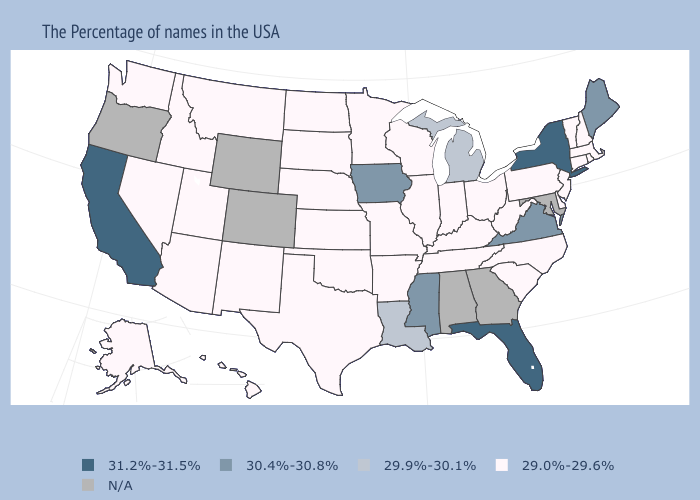Name the states that have a value in the range 29.0%-29.6%?
Give a very brief answer. Massachusetts, Rhode Island, New Hampshire, Vermont, Connecticut, New Jersey, Delaware, Pennsylvania, North Carolina, South Carolina, West Virginia, Ohio, Kentucky, Indiana, Tennessee, Wisconsin, Illinois, Missouri, Arkansas, Minnesota, Kansas, Nebraska, Oklahoma, Texas, South Dakota, North Dakota, New Mexico, Utah, Montana, Arizona, Idaho, Nevada, Washington, Alaska, Hawaii. Does the map have missing data?
Answer briefly. Yes. What is the lowest value in the West?
Answer briefly. 29.0%-29.6%. Name the states that have a value in the range 29.9%-30.1%?
Answer briefly. Michigan, Louisiana. Does the map have missing data?
Short answer required. Yes. Among the states that border New Mexico , which have the highest value?
Concise answer only. Oklahoma, Texas, Utah, Arizona. What is the lowest value in the USA?
Concise answer only. 29.0%-29.6%. Which states have the lowest value in the South?
Answer briefly. Delaware, North Carolina, South Carolina, West Virginia, Kentucky, Tennessee, Arkansas, Oklahoma, Texas. Name the states that have a value in the range 29.9%-30.1%?
Concise answer only. Michigan, Louisiana. What is the value of Washington?
Short answer required. 29.0%-29.6%. Name the states that have a value in the range 31.2%-31.5%?
Concise answer only. New York, Florida, California. What is the highest value in states that border Tennessee?
Be succinct. 30.4%-30.8%. What is the value of Louisiana?
Write a very short answer. 29.9%-30.1%. 